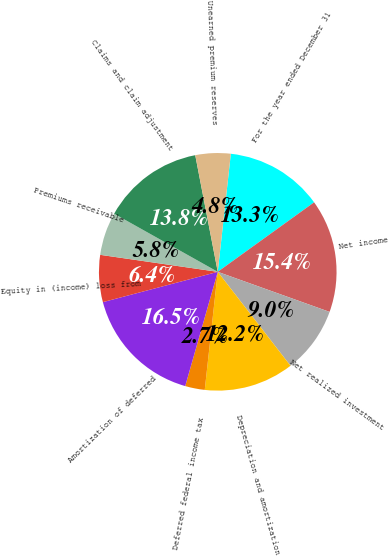Convert chart. <chart><loc_0><loc_0><loc_500><loc_500><pie_chart><fcel>For the year ended December 31<fcel>Net income<fcel>Net realized investment<fcel>Depreciation and amortization<fcel>Deferred federal income tax<fcel>Amortization of deferred<fcel>Equity in (income) loss from<fcel>Premiums receivable<fcel>Claims and claim adjustment<fcel>Unearned premium reserves<nl><fcel>13.3%<fcel>15.42%<fcel>9.04%<fcel>12.23%<fcel>2.67%<fcel>16.48%<fcel>6.39%<fcel>5.85%<fcel>13.83%<fcel>4.79%<nl></chart> 